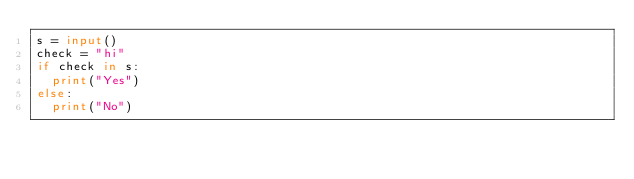<code> <loc_0><loc_0><loc_500><loc_500><_Python_>s = input()
check = "hi"
if check in s:
  print("Yes")
else:
  print("No")
</code> 